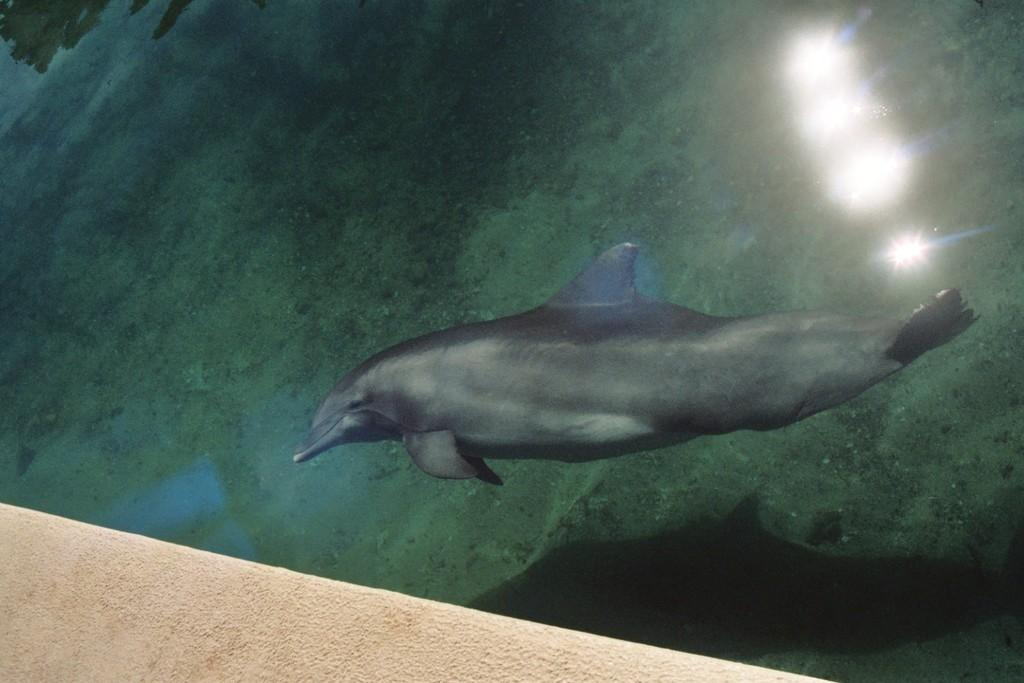What animal is featured in the image? There is a dolphin in the image. What is the dolphin doing in the image? The dolphin is swimming in the water. What can be seen in the background of the image? There is water visible in the background of the image. How much sugar is in the pancake that the dolphin is eating in the image? There is no pancake or sugar present in the image; it features a dolphin swimming in the water. 